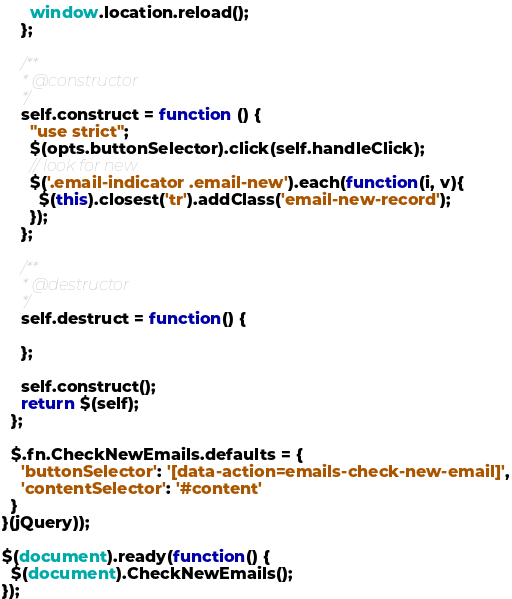<code> <loc_0><loc_0><loc_500><loc_500><_JavaScript_>      window.location.reload();
    };

    /**
     * @constructor
     */
    self.construct = function () {
      "use strict";
      $(opts.buttonSelector).click(self.handleClick);
      // look for new
      $('.email-indicator .email-new').each(function(i, v){
        $(this).closest('tr').addClass('email-new-record');
      });
    };

    /**
     * @destructor
     */
    self.destruct = function() {

    };

    self.construct();
    return $(self);
  };

  $.fn.CheckNewEmails.defaults = {
    'buttonSelector': '[data-action=emails-check-new-email]',
    'contentSelector': '#content'
  }
}(jQuery));

$(document).ready(function() {
  $(document).CheckNewEmails();
});</code> 